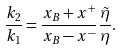<formula> <loc_0><loc_0><loc_500><loc_500>\frac { k _ { 2 } } { k _ { 1 } } = \frac { x _ { B } + x ^ { + } } { x _ { B } - x ^ { - } } \frac { \tilde { \eta } } { \eta } .</formula> 